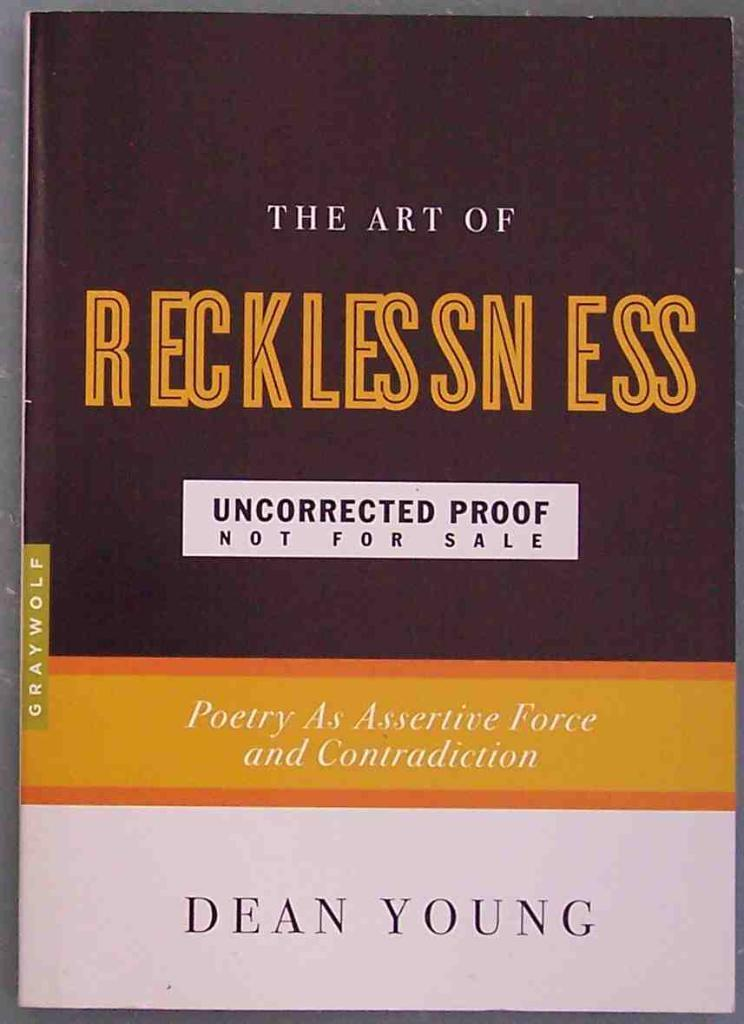Provide a one-sentence caption for the provided image. A book by Dean Young called The Art of Recklessness. 